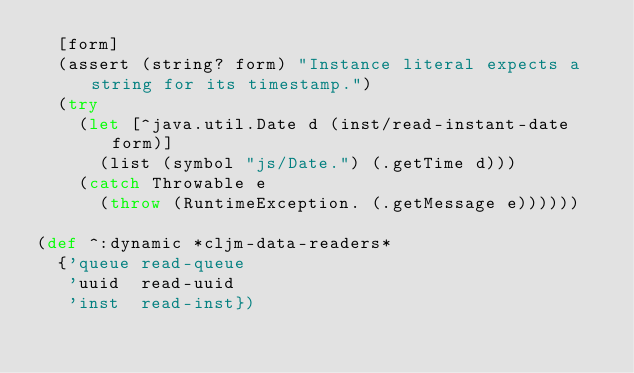Convert code to text. <code><loc_0><loc_0><loc_500><loc_500><_Clojure_>  [form]
  (assert (string? form) "Instance literal expects a string for its timestamp.")
  (try
    (let [^java.util.Date d (inst/read-instant-date form)]
      (list (symbol "js/Date.") (.getTime d)))
    (catch Throwable e
      (throw (RuntimeException. (.getMessage e))))))

(def ^:dynamic *cljm-data-readers*
  {'queue read-queue
   'uuid  read-uuid
   'inst  read-inst})
</code> 